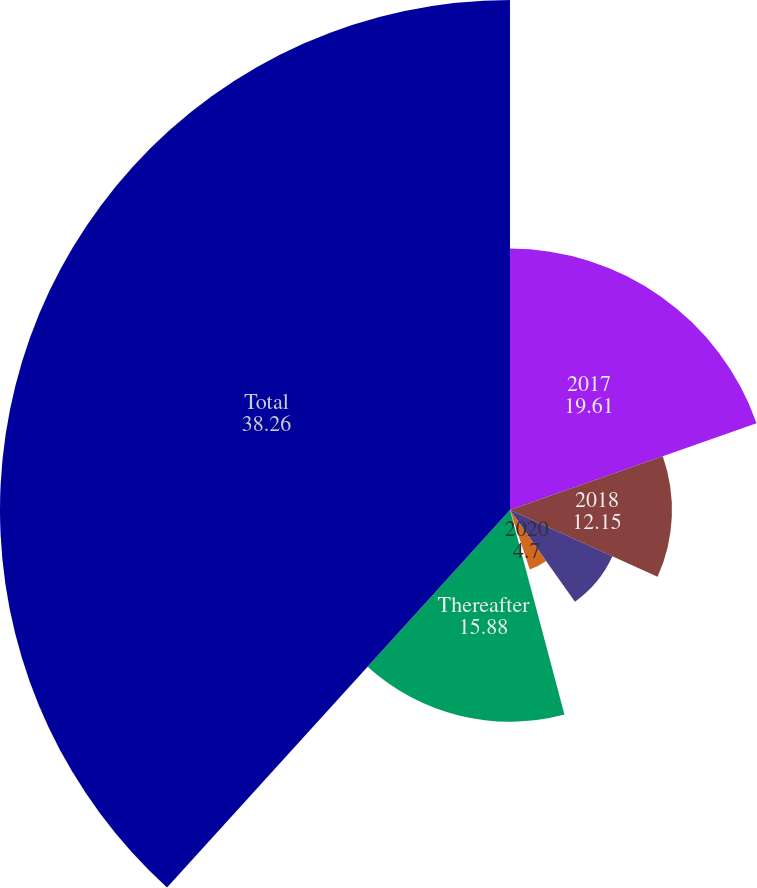<chart> <loc_0><loc_0><loc_500><loc_500><pie_chart><fcel>2017<fcel>2018<fcel>2019<fcel>2020<fcel>2021<fcel>Thereafter<fcel>Total<nl><fcel>19.61%<fcel>12.15%<fcel>8.43%<fcel>4.7%<fcel>0.97%<fcel>15.88%<fcel>38.26%<nl></chart> 